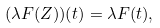<formula> <loc_0><loc_0><loc_500><loc_500>( \lambda F ( Z ) ) ( t ) = \lambda F ( t ) ,</formula> 